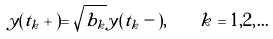Convert formula to latex. <formula><loc_0><loc_0><loc_500><loc_500>y ( t _ { k } + ) = \sqrt { b _ { k } } y ( t _ { k } - ) , \quad k = 1 , 2 , \dots</formula> 